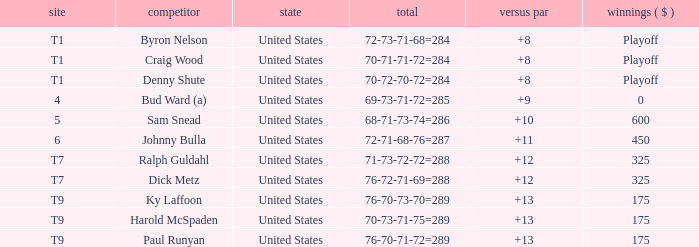What was the country for Sam Snead? United States. 